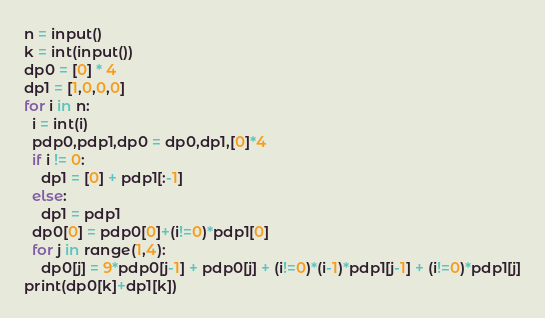Convert code to text. <code><loc_0><loc_0><loc_500><loc_500><_Python_>n = input()
k = int(input())
dp0 = [0] * 4
dp1 = [1,0,0,0]
for i in n:
  i = int(i)
  pdp0,pdp1,dp0 = dp0,dp1,[0]*4
  if i != 0:
    dp1 = [0] + pdp1[:-1]
  else:
    dp1 = pdp1
  dp0[0] = pdp0[0]+(i!=0)*pdp1[0]
  for j in range(1,4):
    dp0[j] = 9*pdp0[j-1] + pdp0[j] + (i!=0)*(i-1)*pdp1[j-1] + (i!=0)*pdp1[j]
print(dp0[k]+dp1[k])</code> 